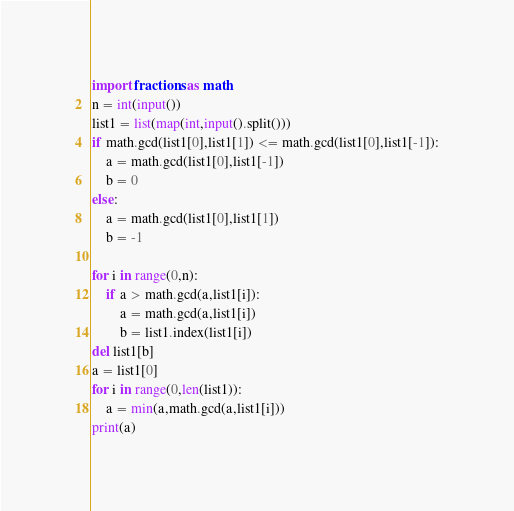<code> <loc_0><loc_0><loc_500><loc_500><_Python_>
import fractions as math
n = int(input())
list1 = list(map(int,input().split()))
if math.gcd(list1[0],list1[1]) <= math.gcd(list1[0],list1[-1]):
	a = math.gcd(list1[0],list1[-1])
	b = 0
else:
	a = math.gcd(list1[0],list1[1])
	b = -1

for i in range(0,n):
	if a > math.gcd(a,list1[i]):
		a = math.gcd(a,list1[i])
		b = list1.index(list1[i])
del list1[b]
a = list1[0]
for i in range(0,len(list1)):
	a = min(a,math.gcd(a,list1[i]))
print(a)
</code> 